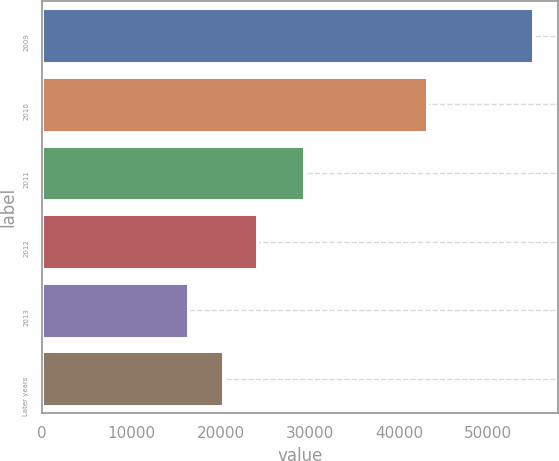Convert chart to OTSL. <chart><loc_0><loc_0><loc_500><loc_500><bar_chart><fcel>2009<fcel>2010<fcel>2011<fcel>2012<fcel>2013<fcel>Later years<nl><fcel>55042<fcel>43091<fcel>29383<fcel>24099.6<fcel>16364<fcel>20231.8<nl></chart> 